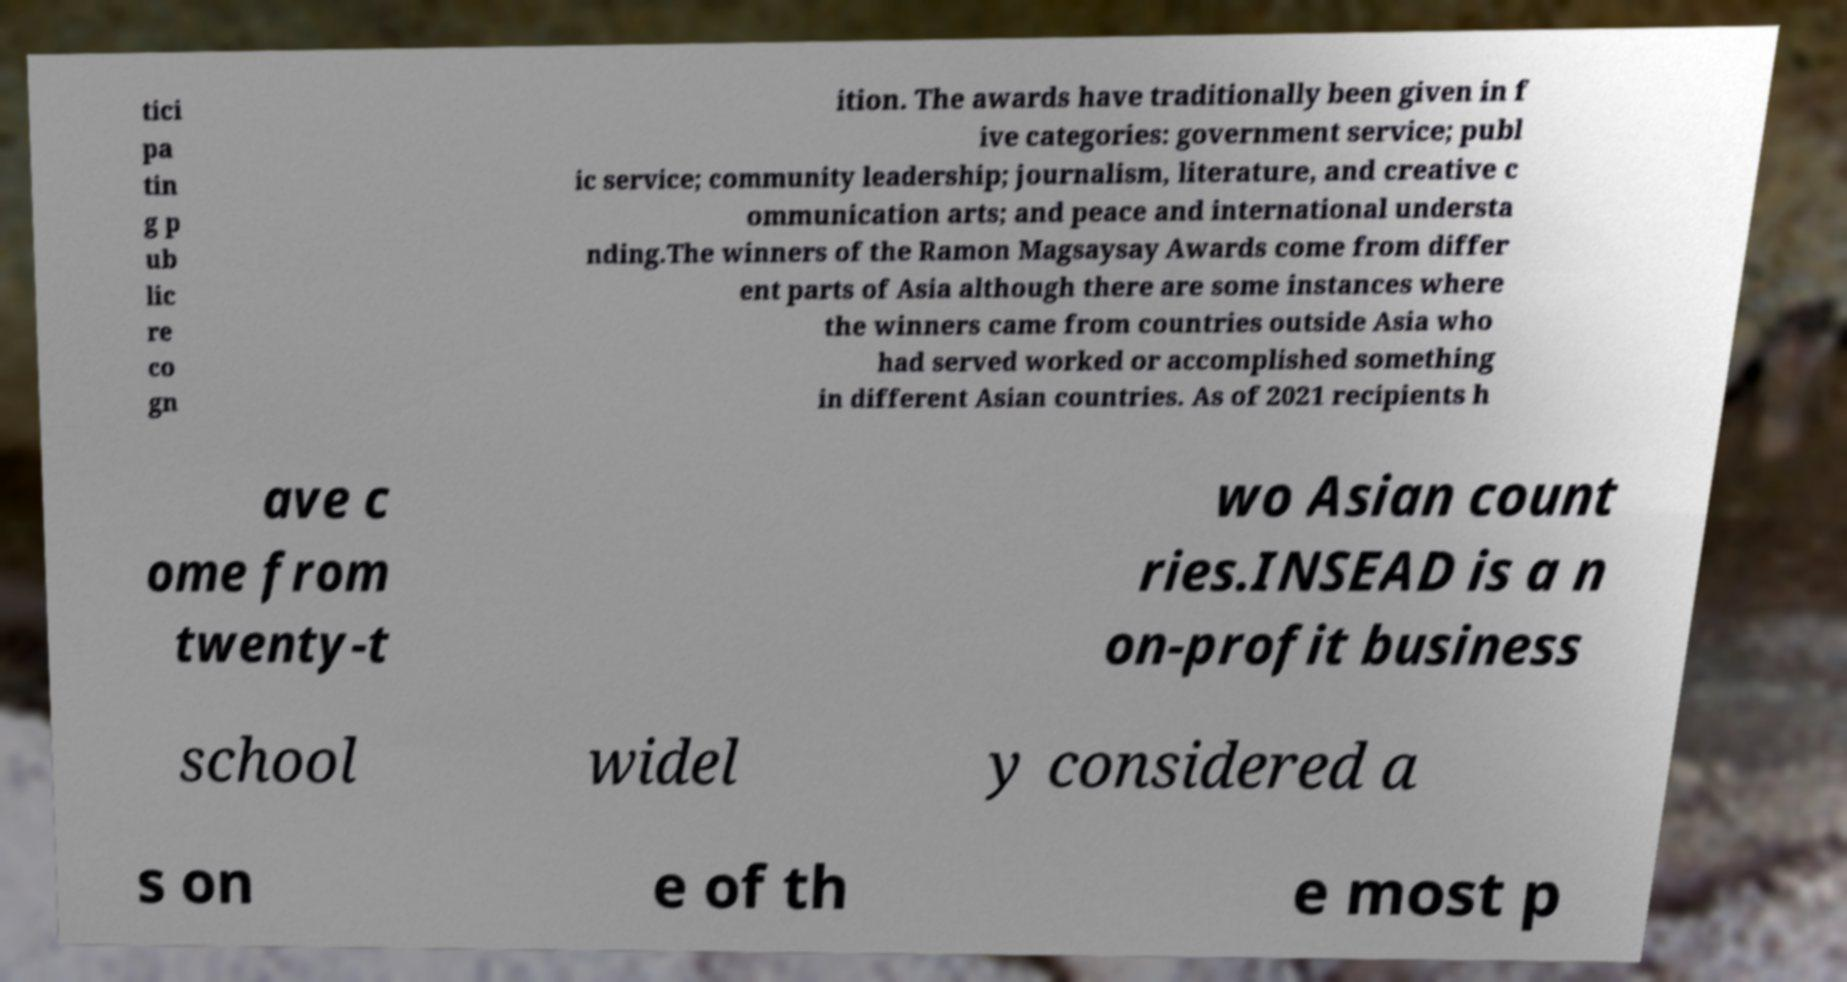I need the written content from this picture converted into text. Can you do that? tici pa tin g p ub lic re co gn ition. The awards have traditionally been given in f ive categories: government service; publ ic service; community leadership; journalism, literature, and creative c ommunication arts; and peace and international understa nding.The winners of the Ramon Magsaysay Awards come from differ ent parts of Asia although there are some instances where the winners came from countries outside Asia who had served worked or accomplished something in different Asian countries. As of 2021 recipients h ave c ome from twenty-t wo Asian count ries.INSEAD is a n on-profit business school widel y considered a s on e of th e most p 